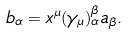<formula> <loc_0><loc_0><loc_500><loc_500>b _ { \alpha } = x ^ { \mu } ( \gamma _ { \mu } ) _ { \alpha } ^ { \beta } a _ { \beta } .</formula> 